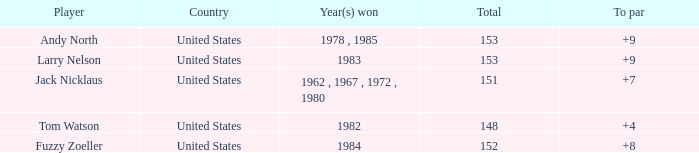What is Andy North with a To par greater than 8 Country? United States. 